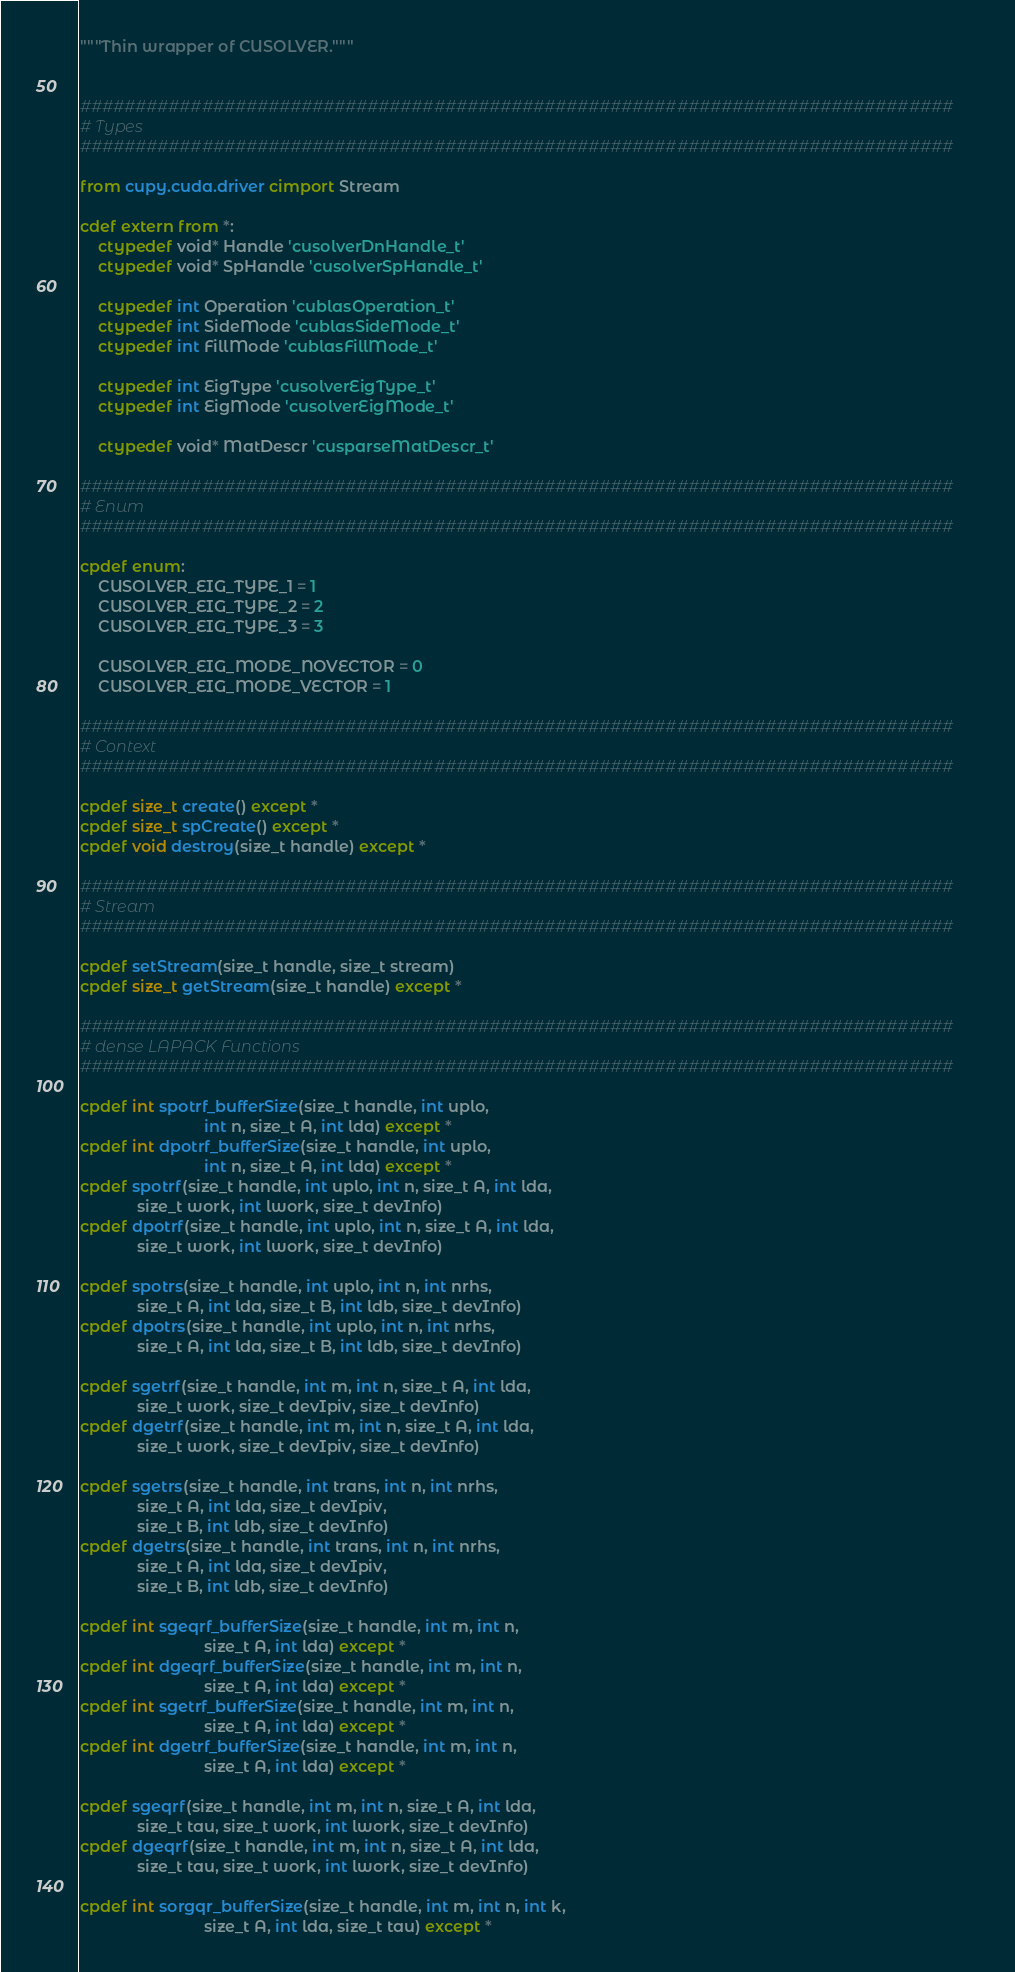<code> <loc_0><loc_0><loc_500><loc_500><_Cython_>"""Thin wrapper of CUSOLVER."""


###############################################################################
# Types
###############################################################################

from cupy.cuda.driver cimport Stream

cdef extern from *:
    ctypedef void* Handle 'cusolverDnHandle_t'
    ctypedef void* SpHandle 'cusolverSpHandle_t'

    ctypedef int Operation 'cublasOperation_t'
    ctypedef int SideMode 'cublasSideMode_t'
    ctypedef int FillMode 'cublasFillMode_t'

    ctypedef int EigType 'cusolverEigType_t'
    ctypedef int EigMode 'cusolverEigMode_t'

    ctypedef void* MatDescr 'cusparseMatDescr_t'

###############################################################################
# Enum
###############################################################################

cpdef enum:
    CUSOLVER_EIG_TYPE_1 = 1
    CUSOLVER_EIG_TYPE_2 = 2
    CUSOLVER_EIG_TYPE_3 = 3

    CUSOLVER_EIG_MODE_NOVECTOR = 0
    CUSOLVER_EIG_MODE_VECTOR = 1

###############################################################################
# Context
###############################################################################

cpdef size_t create() except *
cpdef size_t spCreate() except *
cpdef void destroy(size_t handle) except *

###############################################################################
# Stream
###############################################################################

cpdef setStream(size_t handle, size_t stream)
cpdef size_t getStream(size_t handle) except *

###############################################################################
# dense LAPACK Functions
###############################################################################

cpdef int spotrf_bufferSize(size_t handle, int uplo,
                            int n, size_t A, int lda) except *
cpdef int dpotrf_bufferSize(size_t handle, int uplo,
                            int n, size_t A, int lda) except *
cpdef spotrf(size_t handle, int uplo, int n, size_t A, int lda,
             size_t work, int lwork, size_t devInfo)
cpdef dpotrf(size_t handle, int uplo, int n, size_t A, int lda,
             size_t work, int lwork, size_t devInfo)

cpdef spotrs(size_t handle, int uplo, int n, int nrhs,
             size_t A, int lda, size_t B, int ldb, size_t devInfo)
cpdef dpotrs(size_t handle, int uplo, int n, int nrhs,
             size_t A, int lda, size_t B, int ldb, size_t devInfo)

cpdef sgetrf(size_t handle, int m, int n, size_t A, int lda,
             size_t work, size_t devIpiv, size_t devInfo)
cpdef dgetrf(size_t handle, int m, int n, size_t A, int lda,
             size_t work, size_t devIpiv, size_t devInfo)

cpdef sgetrs(size_t handle, int trans, int n, int nrhs,
             size_t A, int lda, size_t devIpiv,
             size_t B, int ldb, size_t devInfo)
cpdef dgetrs(size_t handle, int trans, int n, int nrhs,
             size_t A, int lda, size_t devIpiv,
             size_t B, int ldb, size_t devInfo)

cpdef int sgeqrf_bufferSize(size_t handle, int m, int n,
                            size_t A, int lda) except *
cpdef int dgeqrf_bufferSize(size_t handle, int m, int n,
                            size_t A, int lda) except *
cpdef int sgetrf_bufferSize(size_t handle, int m, int n,
                            size_t A, int lda) except *
cpdef int dgetrf_bufferSize(size_t handle, int m, int n,
                            size_t A, int lda) except *

cpdef sgeqrf(size_t handle, int m, int n, size_t A, int lda,
             size_t tau, size_t work, int lwork, size_t devInfo)
cpdef dgeqrf(size_t handle, int m, int n, size_t A, int lda,
             size_t tau, size_t work, int lwork, size_t devInfo)

cpdef int sorgqr_bufferSize(size_t handle, int m, int n, int k,
                            size_t A, int lda, size_t tau) except *</code> 